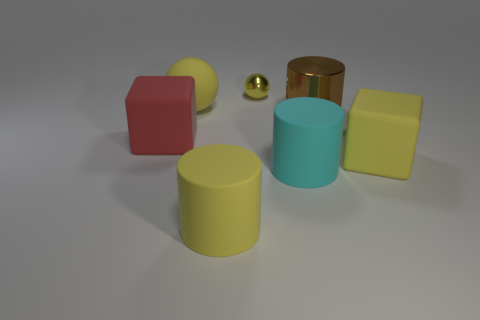Subtract all yellow spheres. How many were subtracted if there are1yellow spheres left? 1 Subtract all brown spheres. Subtract all yellow blocks. How many spheres are left? 2 Add 2 large yellow rubber things. How many objects exist? 9 Subtract all cylinders. How many objects are left? 4 Add 7 cyan cylinders. How many cyan cylinders exist? 8 Subtract 0 purple cubes. How many objects are left? 7 Subtract all small cyan matte cylinders. Subtract all large yellow matte cubes. How many objects are left? 6 Add 6 tiny yellow shiny balls. How many tiny yellow shiny balls are left? 7 